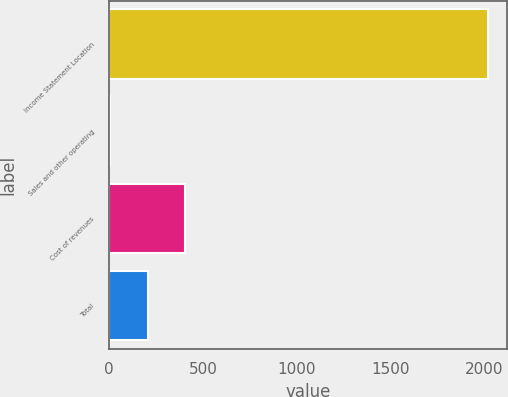Convert chart to OTSL. <chart><loc_0><loc_0><loc_500><loc_500><bar_chart><fcel>Income Statement Location<fcel>Sales and other operating<fcel>Cost of revenues<fcel>Total<nl><fcel>2017<fcel>5<fcel>407.4<fcel>206.2<nl></chart> 